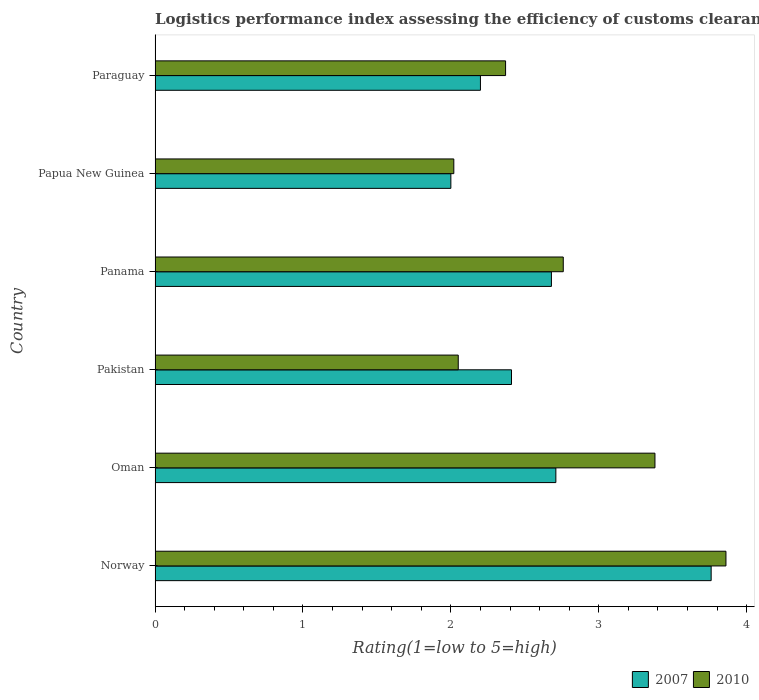How many different coloured bars are there?
Provide a short and direct response. 2. How many groups of bars are there?
Give a very brief answer. 6. Are the number of bars per tick equal to the number of legend labels?
Keep it short and to the point. Yes. What is the label of the 5th group of bars from the top?
Your response must be concise. Oman. In how many cases, is the number of bars for a given country not equal to the number of legend labels?
Provide a succinct answer. 0. What is the Logistic performance index in 2007 in Paraguay?
Ensure brevity in your answer.  2.2. Across all countries, what is the maximum Logistic performance index in 2010?
Provide a short and direct response. 3.86. Across all countries, what is the minimum Logistic performance index in 2010?
Offer a terse response. 2.02. In which country was the Logistic performance index in 2010 maximum?
Offer a very short reply. Norway. In which country was the Logistic performance index in 2007 minimum?
Offer a terse response. Papua New Guinea. What is the total Logistic performance index in 2007 in the graph?
Provide a succinct answer. 15.76. What is the difference between the Logistic performance index in 2007 in Panama and that in Papua New Guinea?
Offer a very short reply. 0.68. What is the difference between the Logistic performance index in 2010 in Paraguay and the Logistic performance index in 2007 in Pakistan?
Ensure brevity in your answer.  -0.04. What is the average Logistic performance index in 2007 per country?
Provide a succinct answer. 2.63. What is the difference between the Logistic performance index in 2007 and Logistic performance index in 2010 in Oman?
Offer a very short reply. -0.67. In how many countries, is the Logistic performance index in 2007 greater than 3 ?
Keep it short and to the point. 1. What is the ratio of the Logistic performance index in 2007 in Norway to that in Oman?
Your answer should be very brief. 1.39. What is the difference between the highest and the second highest Logistic performance index in 2010?
Make the answer very short. 0.48. What is the difference between the highest and the lowest Logistic performance index in 2007?
Offer a terse response. 1.76. In how many countries, is the Logistic performance index in 2007 greater than the average Logistic performance index in 2007 taken over all countries?
Your response must be concise. 3. How many bars are there?
Make the answer very short. 12. How many countries are there in the graph?
Give a very brief answer. 6. What is the difference between two consecutive major ticks on the X-axis?
Offer a very short reply. 1. Are the values on the major ticks of X-axis written in scientific E-notation?
Give a very brief answer. No. Does the graph contain any zero values?
Give a very brief answer. No. How are the legend labels stacked?
Ensure brevity in your answer.  Horizontal. What is the title of the graph?
Ensure brevity in your answer.  Logistics performance index assessing the efficiency of customs clearance processes. What is the label or title of the X-axis?
Offer a terse response. Rating(1=low to 5=high). What is the Rating(1=low to 5=high) in 2007 in Norway?
Give a very brief answer. 3.76. What is the Rating(1=low to 5=high) in 2010 in Norway?
Give a very brief answer. 3.86. What is the Rating(1=low to 5=high) of 2007 in Oman?
Offer a terse response. 2.71. What is the Rating(1=low to 5=high) of 2010 in Oman?
Keep it short and to the point. 3.38. What is the Rating(1=low to 5=high) in 2007 in Pakistan?
Provide a short and direct response. 2.41. What is the Rating(1=low to 5=high) in 2010 in Pakistan?
Make the answer very short. 2.05. What is the Rating(1=low to 5=high) in 2007 in Panama?
Your response must be concise. 2.68. What is the Rating(1=low to 5=high) in 2010 in Panama?
Provide a short and direct response. 2.76. What is the Rating(1=low to 5=high) in 2007 in Papua New Guinea?
Ensure brevity in your answer.  2. What is the Rating(1=low to 5=high) in 2010 in Papua New Guinea?
Give a very brief answer. 2.02. What is the Rating(1=low to 5=high) in 2007 in Paraguay?
Offer a terse response. 2.2. What is the Rating(1=low to 5=high) of 2010 in Paraguay?
Ensure brevity in your answer.  2.37. Across all countries, what is the maximum Rating(1=low to 5=high) of 2007?
Make the answer very short. 3.76. Across all countries, what is the maximum Rating(1=low to 5=high) of 2010?
Keep it short and to the point. 3.86. Across all countries, what is the minimum Rating(1=low to 5=high) in 2010?
Your response must be concise. 2.02. What is the total Rating(1=low to 5=high) of 2007 in the graph?
Make the answer very short. 15.76. What is the total Rating(1=low to 5=high) of 2010 in the graph?
Ensure brevity in your answer.  16.44. What is the difference between the Rating(1=low to 5=high) in 2010 in Norway and that in Oman?
Offer a very short reply. 0.48. What is the difference between the Rating(1=low to 5=high) in 2007 in Norway and that in Pakistan?
Your response must be concise. 1.35. What is the difference between the Rating(1=low to 5=high) of 2010 in Norway and that in Pakistan?
Offer a terse response. 1.81. What is the difference between the Rating(1=low to 5=high) of 2007 in Norway and that in Panama?
Provide a succinct answer. 1.08. What is the difference between the Rating(1=low to 5=high) in 2007 in Norway and that in Papua New Guinea?
Your answer should be very brief. 1.76. What is the difference between the Rating(1=low to 5=high) in 2010 in Norway and that in Papua New Guinea?
Offer a terse response. 1.84. What is the difference between the Rating(1=low to 5=high) in 2007 in Norway and that in Paraguay?
Ensure brevity in your answer.  1.56. What is the difference between the Rating(1=low to 5=high) of 2010 in Norway and that in Paraguay?
Keep it short and to the point. 1.49. What is the difference between the Rating(1=low to 5=high) in 2007 in Oman and that in Pakistan?
Your response must be concise. 0.3. What is the difference between the Rating(1=low to 5=high) in 2010 in Oman and that in Pakistan?
Provide a succinct answer. 1.33. What is the difference between the Rating(1=low to 5=high) in 2007 in Oman and that in Panama?
Give a very brief answer. 0.03. What is the difference between the Rating(1=low to 5=high) in 2010 in Oman and that in Panama?
Your answer should be compact. 0.62. What is the difference between the Rating(1=low to 5=high) of 2007 in Oman and that in Papua New Guinea?
Keep it short and to the point. 0.71. What is the difference between the Rating(1=low to 5=high) of 2010 in Oman and that in Papua New Guinea?
Provide a short and direct response. 1.36. What is the difference between the Rating(1=low to 5=high) in 2007 in Oman and that in Paraguay?
Offer a terse response. 0.51. What is the difference between the Rating(1=low to 5=high) in 2007 in Pakistan and that in Panama?
Give a very brief answer. -0.27. What is the difference between the Rating(1=low to 5=high) in 2010 in Pakistan and that in Panama?
Keep it short and to the point. -0.71. What is the difference between the Rating(1=low to 5=high) in 2007 in Pakistan and that in Papua New Guinea?
Give a very brief answer. 0.41. What is the difference between the Rating(1=low to 5=high) of 2010 in Pakistan and that in Papua New Guinea?
Your answer should be compact. 0.03. What is the difference between the Rating(1=low to 5=high) in 2007 in Pakistan and that in Paraguay?
Offer a very short reply. 0.21. What is the difference between the Rating(1=low to 5=high) in 2010 in Pakistan and that in Paraguay?
Your answer should be compact. -0.32. What is the difference between the Rating(1=low to 5=high) in 2007 in Panama and that in Papua New Guinea?
Your response must be concise. 0.68. What is the difference between the Rating(1=low to 5=high) in 2010 in Panama and that in Papua New Guinea?
Your response must be concise. 0.74. What is the difference between the Rating(1=low to 5=high) in 2007 in Panama and that in Paraguay?
Your response must be concise. 0.48. What is the difference between the Rating(1=low to 5=high) of 2010 in Panama and that in Paraguay?
Your response must be concise. 0.39. What is the difference between the Rating(1=low to 5=high) in 2010 in Papua New Guinea and that in Paraguay?
Keep it short and to the point. -0.35. What is the difference between the Rating(1=low to 5=high) in 2007 in Norway and the Rating(1=low to 5=high) in 2010 in Oman?
Keep it short and to the point. 0.38. What is the difference between the Rating(1=low to 5=high) in 2007 in Norway and the Rating(1=low to 5=high) in 2010 in Pakistan?
Your answer should be compact. 1.71. What is the difference between the Rating(1=low to 5=high) of 2007 in Norway and the Rating(1=low to 5=high) of 2010 in Papua New Guinea?
Make the answer very short. 1.74. What is the difference between the Rating(1=low to 5=high) in 2007 in Norway and the Rating(1=low to 5=high) in 2010 in Paraguay?
Offer a very short reply. 1.39. What is the difference between the Rating(1=low to 5=high) in 2007 in Oman and the Rating(1=low to 5=high) in 2010 in Pakistan?
Keep it short and to the point. 0.66. What is the difference between the Rating(1=low to 5=high) in 2007 in Oman and the Rating(1=low to 5=high) in 2010 in Papua New Guinea?
Give a very brief answer. 0.69. What is the difference between the Rating(1=low to 5=high) of 2007 in Oman and the Rating(1=low to 5=high) of 2010 in Paraguay?
Ensure brevity in your answer.  0.34. What is the difference between the Rating(1=low to 5=high) in 2007 in Pakistan and the Rating(1=low to 5=high) in 2010 in Panama?
Make the answer very short. -0.35. What is the difference between the Rating(1=low to 5=high) in 2007 in Pakistan and the Rating(1=low to 5=high) in 2010 in Papua New Guinea?
Provide a short and direct response. 0.39. What is the difference between the Rating(1=low to 5=high) in 2007 in Panama and the Rating(1=low to 5=high) in 2010 in Papua New Guinea?
Provide a succinct answer. 0.66. What is the difference between the Rating(1=low to 5=high) in 2007 in Panama and the Rating(1=low to 5=high) in 2010 in Paraguay?
Provide a short and direct response. 0.31. What is the difference between the Rating(1=low to 5=high) in 2007 in Papua New Guinea and the Rating(1=low to 5=high) in 2010 in Paraguay?
Offer a very short reply. -0.37. What is the average Rating(1=low to 5=high) in 2007 per country?
Give a very brief answer. 2.63. What is the average Rating(1=low to 5=high) in 2010 per country?
Offer a terse response. 2.74. What is the difference between the Rating(1=low to 5=high) in 2007 and Rating(1=low to 5=high) in 2010 in Norway?
Your response must be concise. -0.1. What is the difference between the Rating(1=low to 5=high) in 2007 and Rating(1=low to 5=high) in 2010 in Oman?
Provide a succinct answer. -0.67. What is the difference between the Rating(1=low to 5=high) in 2007 and Rating(1=low to 5=high) in 2010 in Pakistan?
Provide a succinct answer. 0.36. What is the difference between the Rating(1=low to 5=high) of 2007 and Rating(1=low to 5=high) of 2010 in Panama?
Your answer should be very brief. -0.08. What is the difference between the Rating(1=low to 5=high) in 2007 and Rating(1=low to 5=high) in 2010 in Papua New Guinea?
Offer a terse response. -0.02. What is the difference between the Rating(1=low to 5=high) of 2007 and Rating(1=low to 5=high) of 2010 in Paraguay?
Offer a terse response. -0.17. What is the ratio of the Rating(1=low to 5=high) in 2007 in Norway to that in Oman?
Your response must be concise. 1.39. What is the ratio of the Rating(1=low to 5=high) in 2010 in Norway to that in Oman?
Keep it short and to the point. 1.14. What is the ratio of the Rating(1=low to 5=high) in 2007 in Norway to that in Pakistan?
Provide a succinct answer. 1.56. What is the ratio of the Rating(1=low to 5=high) of 2010 in Norway to that in Pakistan?
Keep it short and to the point. 1.88. What is the ratio of the Rating(1=low to 5=high) in 2007 in Norway to that in Panama?
Offer a terse response. 1.4. What is the ratio of the Rating(1=low to 5=high) in 2010 in Norway to that in Panama?
Make the answer very short. 1.4. What is the ratio of the Rating(1=low to 5=high) in 2007 in Norway to that in Papua New Guinea?
Give a very brief answer. 1.88. What is the ratio of the Rating(1=low to 5=high) of 2010 in Norway to that in Papua New Guinea?
Offer a terse response. 1.91. What is the ratio of the Rating(1=low to 5=high) of 2007 in Norway to that in Paraguay?
Offer a terse response. 1.71. What is the ratio of the Rating(1=low to 5=high) of 2010 in Norway to that in Paraguay?
Your answer should be very brief. 1.63. What is the ratio of the Rating(1=low to 5=high) in 2007 in Oman to that in Pakistan?
Offer a terse response. 1.12. What is the ratio of the Rating(1=low to 5=high) in 2010 in Oman to that in Pakistan?
Your answer should be compact. 1.65. What is the ratio of the Rating(1=low to 5=high) of 2007 in Oman to that in Panama?
Provide a short and direct response. 1.01. What is the ratio of the Rating(1=low to 5=high) of 2010 in Oman to that in Panama?
Your answer should be compact. 1.22. What is the ratio of the Rating(1=low to 5=high) in 2007 in Oman to that in Papua New Guinea?
Offer a terse response. 1.35. What is the ratio of the Rating(1=low to 5=high) of 2010 in Oman to that in Papua New Guinea?
Offer a very short reply. 1.67. What is the ratio of the Rating(1=low to 5=high) in 2007 in Oman to that in Paraguay?
Provide a succinct answer. 1.23. What is the ratio of the Rating(1=low to 5=high) in 2010 in Oman to that in Paraguay?
Make the answer very short. 1.43. What is the ratio of the Rating(1=low to 5=high) in 2007 in Pakistan to that in Panama?
Provide a succinct answer. 0.9. What is the ratio of the Rating(1=low to 5=high) of 2010 in Pakistan to that in Panama?
Keep it short and to the point. 0.74. What is the ratio of the Rating(1=low to 5=high) in 2007 in Pakistan to that in Papua New Guinea?
Offer a terse response. 1.21. What is the ratio of the Rating(1=low to 5=high) in 2010 in Pakistan to that in Papua New Guinea?
Ensure brevity in your answer.  1.01. What is the ratio of the Rating(1=low to 5=high) of 2007 in Pakistan to that in Paraguay?
Keep it short and to the point. 1.1. What is the ratio of the Rating(1=low to 5=high) of 2010 in Pakistan to that in Paraguay?
Give a very brief answer. 0.86. What is the ratio of the Rating(1=low to 5=high) in 2007 in Panama to that in Papua New Guinea?
Offer a very short reply. 1.34. What is the ratio of the Rating(1=low to 5=high) in 2010 in Panama to that in Papua New Guinea?
Ensure brevity in your answer.  1.37. What is the ratio of the Rating(1=low to 5=high) of 2007 in Panama to that in Paraguay?
Your answer should be compact. 1.22. What is the ratio of the Rating(1=low to 5=high) of 2010 in Panama to that in Paraguay?
Ensure brevity in your answer.  1.16. What is the ratio of the Rating(1=low to 5=high) of 2007 in Papua New Guinea to that in Paraguay?
Offer a terse response. 0.91. What is the ratio of the Rating(1=low to 5=high) of 2010 in Papua New Guinea to that in Paraguay?
Keep it short and to the point. 0.85. What is the difference between the highest and the second highest Rating(1=low to 5=high) of 2010?
Offer a terse response. 0.48. What is the difference between the highest and the lowest Rating(1=low to 5=high) in 2007?
Your answer should be compact. 1.76. What is the difference between the highest and the lowest Rating(1=low to 5=high) of 2010?
Ensure brevity in your answer.  1.84. 